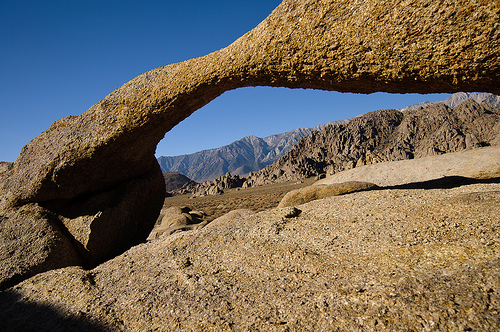<image>
Is the rock on the ground? Yes. Looking at the image, I can see the rock is positioned on top of the ground, with the ground providing support. 